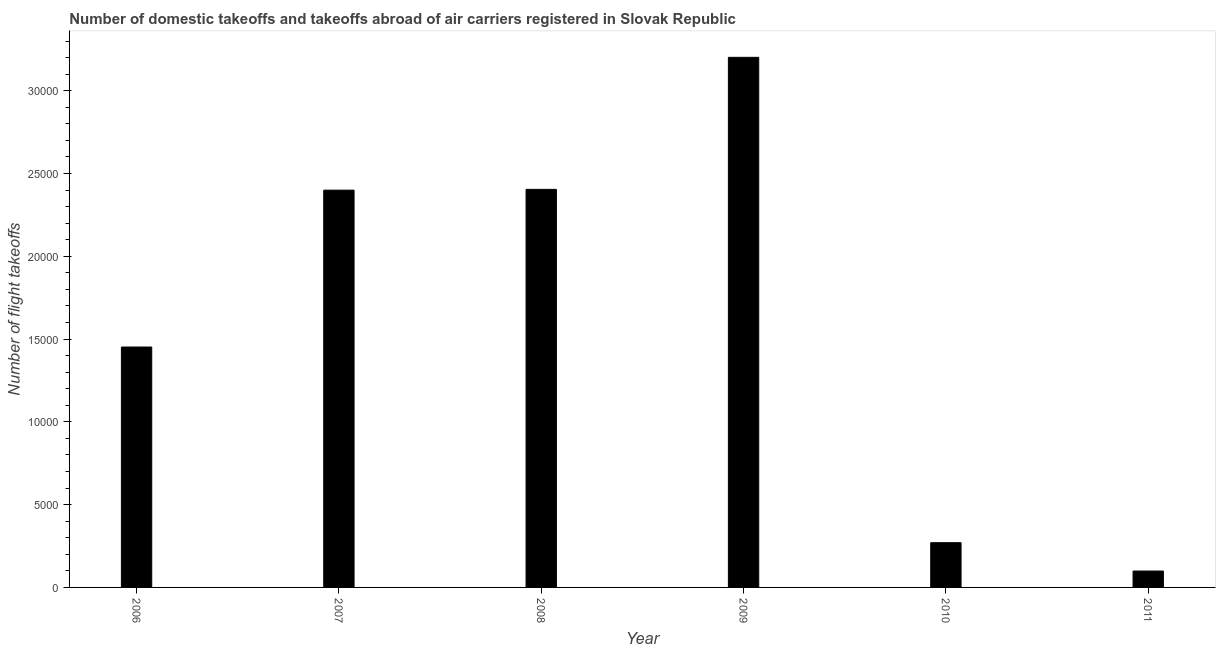Does the graph contain grids?
Ensure brevity in your answer.  No. What is the title of the graph?
Give a very brief answer. Number of domestic takeoffs and takeoffs abroad of air carriers registered in Slovak Republic. What is the label or title of the X-axis?
Make the answer very short. Year. What is the label or title of the Y-axis?
Your response must be concise. Number of flight takeoffs. What is the number of flight takeoffs in 2007?
Provide a succinct answer. 2.40e+04. Across all years, what is the maximum number of flight takeoffs?
Your answer should be very brief. 3.20e+04. Across all years, what is the minimum number of flight takeoffs?
Keep it short and to the point. 990. What is the sum of the number of flight takeoffs?
Give a very brief answer. 9.83e+04. What is the difference between the number of flight takeoffs in 2008 and 2011?
Provide a short and direct response. 2.31e+04. What is the average number of flight takeoffs per year?
Your answer should be very brief. 1.64e+04. What is the median number of flight takeoffs?
Keep it short and to the point. 1.93e+04. What is the ratio of the number of flight takeoffs in 2007 to that in 2010?
Your answer should be compact. 8.88. What is the difference between the highest and the second highest number of flight takeoffs?
Your answer should be compact. 7976. What is the difference between the highest and the lowest number of flight takeoffs?
Provide a succinct answer. 3.10e+04. How many bars are there?
Offer a terse response. 6. How many years are there in the graph?
Your answer should be compact. 6. What is the difference between two consecutive major ticks on the Y-axis?
Your answer should be very brief. 5000. Are the values on the major ticks of Y-axis written in scientific E-notation?
Make the answer very short. No. What is the Number of flight takeoffs in 2006?
Your answer should be compact. 1.45e+04. What is the Number of flight takeoffs of 2007?
Your answer should be very brief. 2.40e+04. What is the Number of flight takeoffs of 2008?
Make the answer very short. 2.40e+04. What is the Number of flight takeoffs in 2009?
Your response must be concise. 3.20e+04. What is the Number of flight takeoffs in 2010?
Your answer should be compact. 2702. What is the Number of flight takeoffs in 2011?
Your answer should be very brief. 990. What is the difference between the Number of flight takeoffs in 2006 and 2007?
Make the answer very short. -9476. What is the difference between the Number of flight takeoffs in 2006 and 2008?
Make the answer very short. -9523. What is the difference between the Number of flight takeoffs in 2006 and 2009?
Ensure brevity in your answer.  -1.75e+04. What is the difference between the Number of flight takeoffs in 2006 and 2010?
Provide a succinct answer. 1.18e+04. What is the difference between the Number of flight takeoffs in 2006 and 2011?
Offer a very short reply. 1.35e+04. What is the difference between the Number of flight takeoffs in 2007 and 2008?
Provide a short and direct response. -47. What is the difference between the Number of flight takeoffs in 2007 and 2009?
Provide a succinct answer. -8023. What is the difference between the Number of flight takeoffs in 2007 and 2010?
Your response must be concise. 2.13e+04. What is the difference between the Number of flight takeoffs in 2007 and 2011?
Make the answer very short. 2.30e+04. What is the difference between the Number of flight takeoffs in 2008 and 2009?
Offer a very short reply. -7976. What is the difference between the Number of flight takeoffs in 2008 and 2010?
Your answer should be compact. 2.13e+04. What is the difference between the Number of flight takeoffs in 2008 and 2011?
Offer a very short reply. 2.31e+04. What is the difference between the Number of flight takeoffs in 2009 and 2010?
Provide a short and direct response. 2.93e+04. What is the difference between the Number of flight takeoffs in 2009 and 2011?
Offer a very short reply. 3.10e+04. What is the difference between the Number of flight takeoffs in 2010 and 2011?
Ensure brevity in your answer.  1712. What is the ratio of the Number of flight takeoffs in 2006 to that in 2007?
Offer a very short reply. 0.6. What is the ratio of the Number of flight takeoffs in 2006 to that in 2008?
Your answer should be compact. 0.6. What is the ratio of the Number of flight takeoffs in 2006 to that in 2009?
Give a very brief answer. 0.45. What is the ratio of the Number of flight takeoffs in 2006 to that in 2010?
Make the answer very short. 5.37. What is the ratio of the Number of flight takeoffs in 2006 to that in 2011?
Offer a terse response. 14.67. What is the ratio of the Number of flight takeoffs in 2007 to that in 2009?
Your answer should be compact. 0.75. What is the ratio of the Number of flight takeoffs in 2007 to that in 2010?
Provide a short and direct response. 8.88. What is the ratio of the Number of flight takeoffs in 2007 to that in 2011?
Keep it short and to the point. 24.24. What is the ratio of the Number of flight takeoffs in 2008 to that in 2009?
Make the answer very short. 0.75. What is the ratio of the Number of flight takeoffs in 2008 to that in 2010?
Make the answer very short. 8.9. What is the ratio of the Number of flight takeoffs in 2008 to that in 2011?
Keep it short and to the point. 24.29. What is the ratio of the Number of flight takeoffs in 2009 to that in 2010?
Offer a terse response. 11.85. What is the ratio of the Number of flight takeoffs in 2009 to that in 2011?
Keep it short and to the point. 32.34. What is the ratio of the Number of flight takeoffs in 2010 to that in 2011?
Keep it short and to the point. 2.73. 